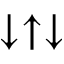Convert formula to latex. <formula><loc_0><loc_0><loc_500><loc_500>\downarrow \uparrow \downarrow</formula> 